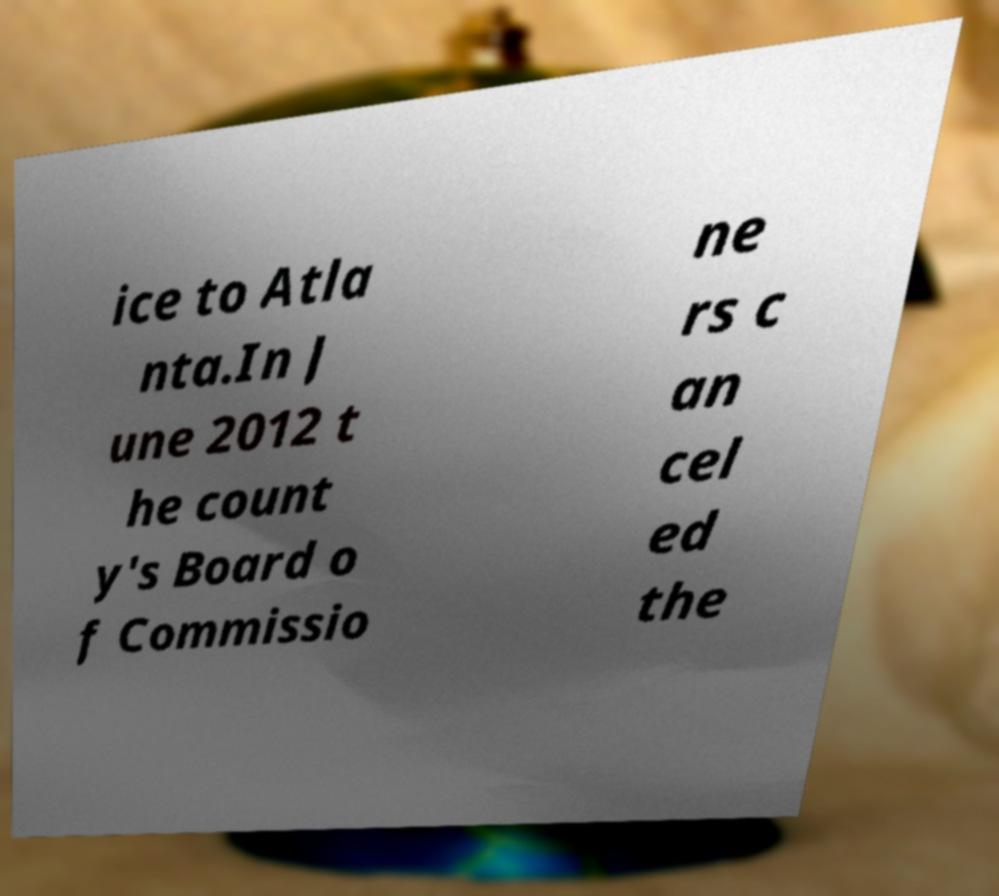Please read and relay the text visible in this image. What does it say? ice to Atla nta.In J une 2012 t he count y's Board o f Commissio ne rs c an cel ed the 